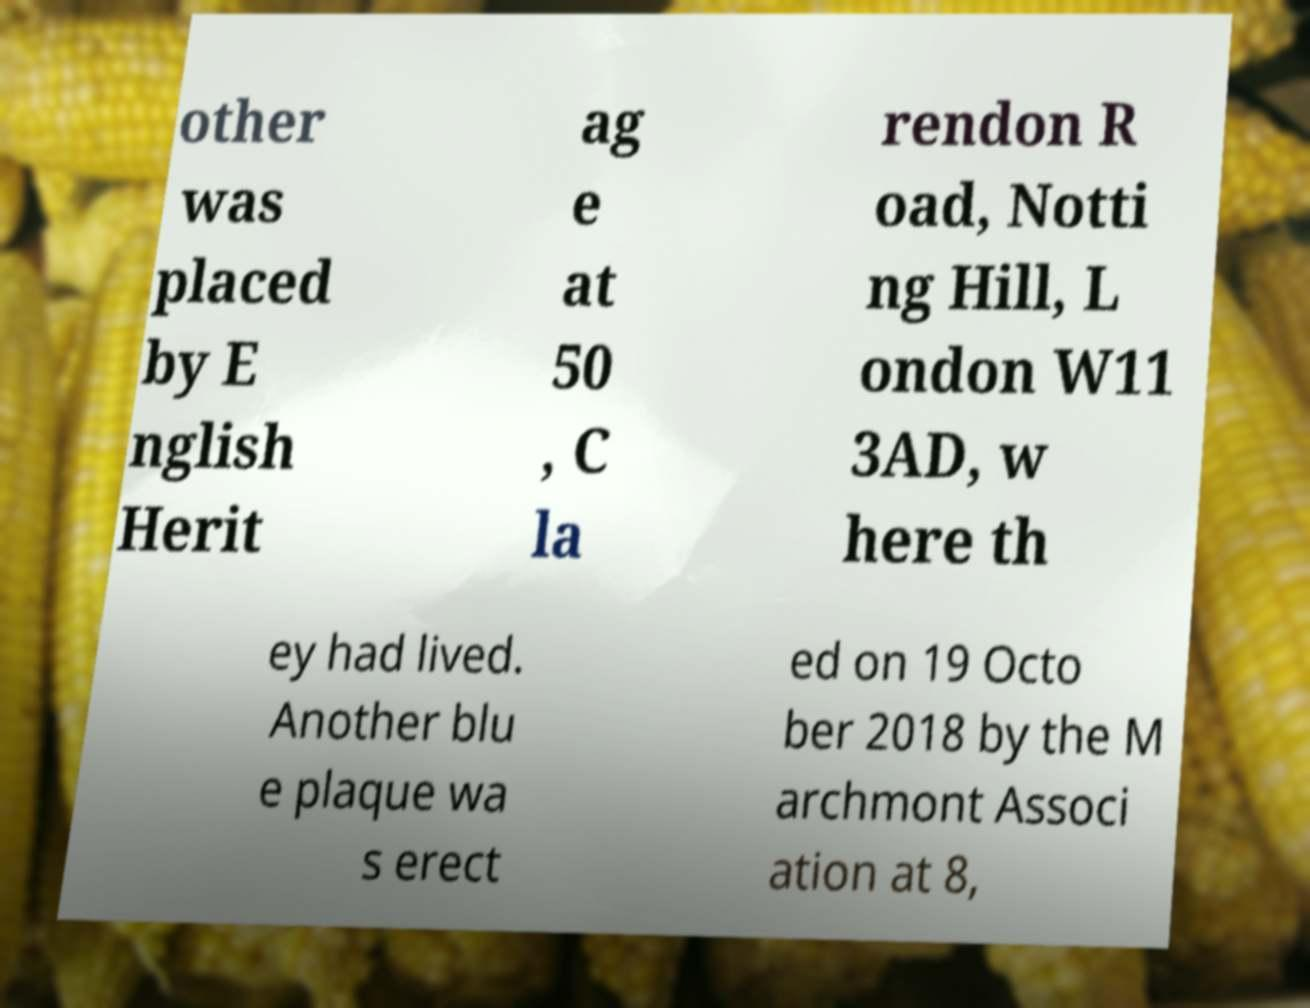For documentation purposes, I need the text within this image transcribed. Could you provide that? other was placed by E nglish Herit ag e at 50 , C la rendon R oad, Notti ng Hill, L ondon W11 3AD, w here th ey had lived. Another blu e plaque wa s erect ed on 19 Octo ber 2018 by the M archmont Associ ation at 8, 